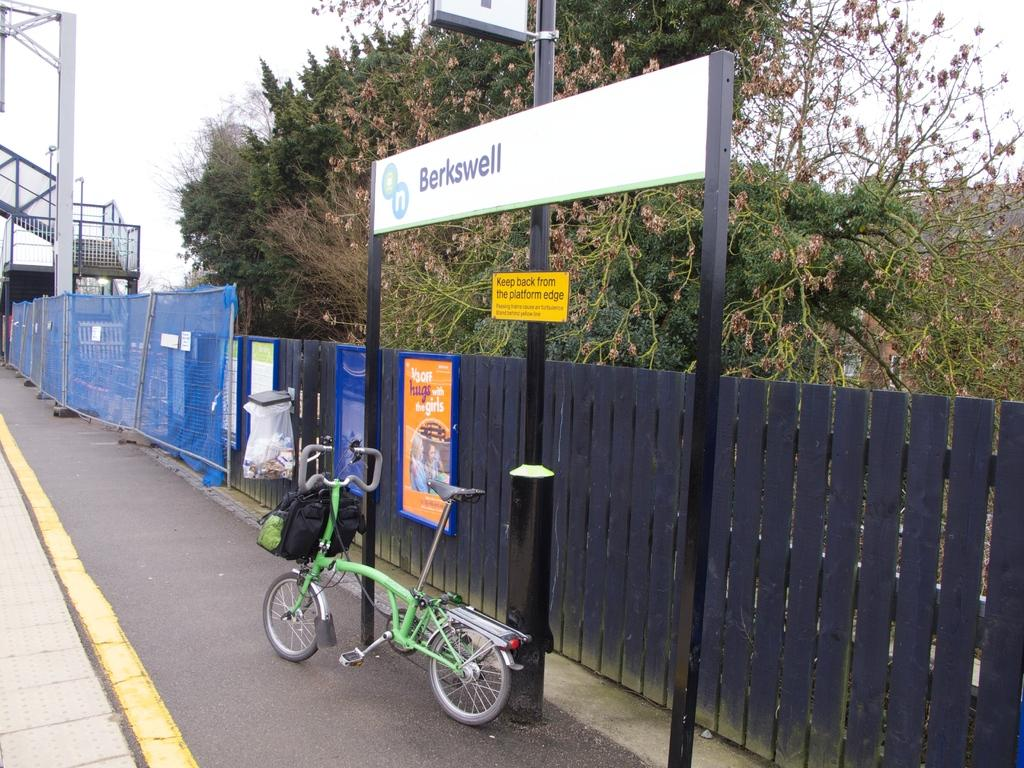What is the main subject in the center of the image? There is a bicycle in the center of the image. What can be seen on the right side of the image? There is a fence, a board, and a net on the right side of the image. What is visible in the background of the image? There are trees, stairs, and the sky visible in the background of the image. What type of apparel are the children wearing in the image? There are no children present in the image, so it is not possible to determine what type of apparel they might be wearing. 